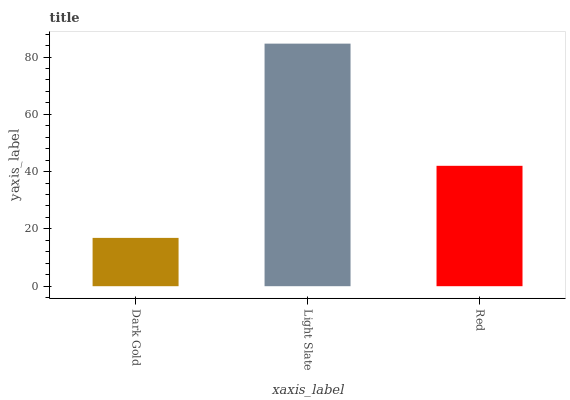Is Dark Gold the minimum?
Answer yes or no. Yes. Is Light Slate the maximum?
Answer yes or no. Yes. Is Red the minimum?
Answer yes or no. No. Is Red the maximum?
Answer yes or no. No. Is Light Slate greater than Red?
Answer yes or no. Yes. Is Red less than Light Slate?
Answer yes or no. Yes. Is Red greater than Light Slate?
Answer yes or no. No. Is Light Slate less than Red?
Answer yes or no. No. Is Red the high median?
Answer yes or no. Yes. Is Red the low median?
Answer yes or no. Yes. Is Light Slate the high median?
Answer yes or no. No. Is Light Slate the low median?
Answer yes or no. No. 